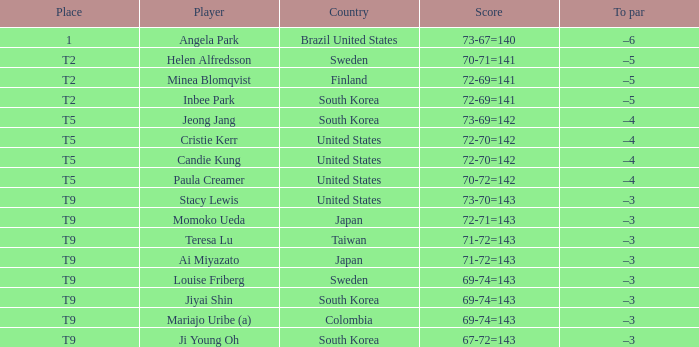Which country placed t9 and had the player jiyai shin? South Korea. 